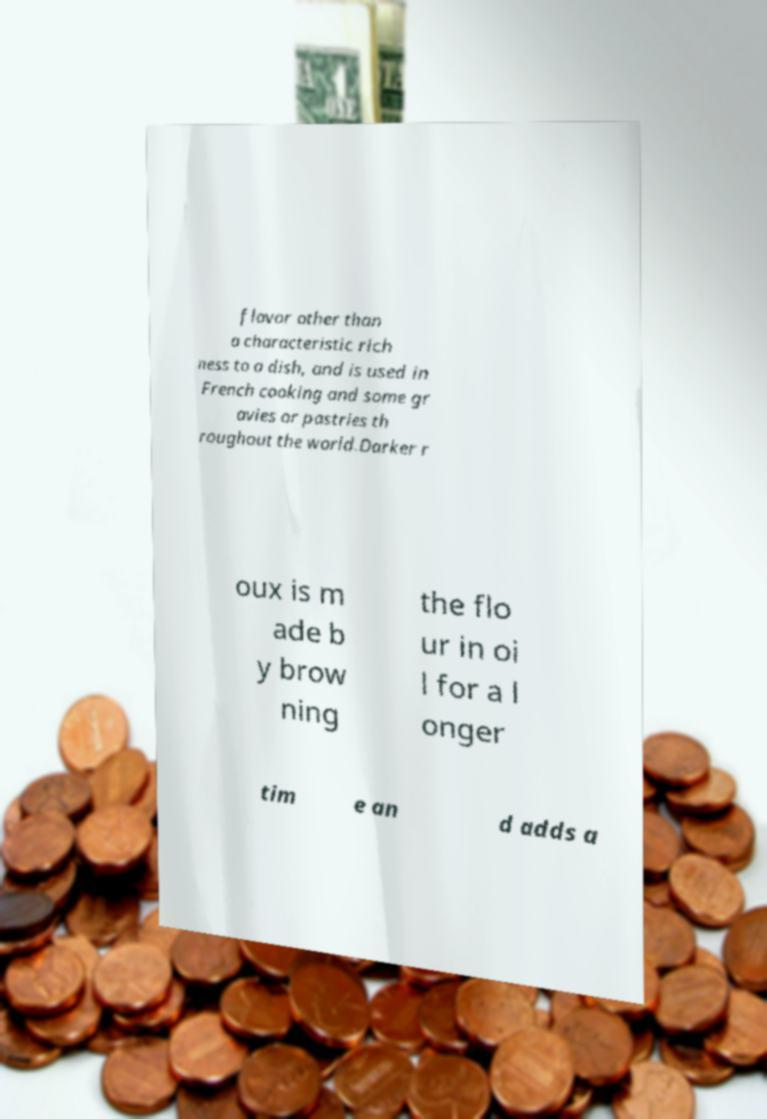I need the written content from this picture converted into text. Can you do that? flavor other than a characteristic rich ness to a dish, and is used in French cooking and some gr avies or pastries th roughout the world.Darker r oux is m ade b y brow ning the flo ur in oi l for a l onger tim e an d adds a 